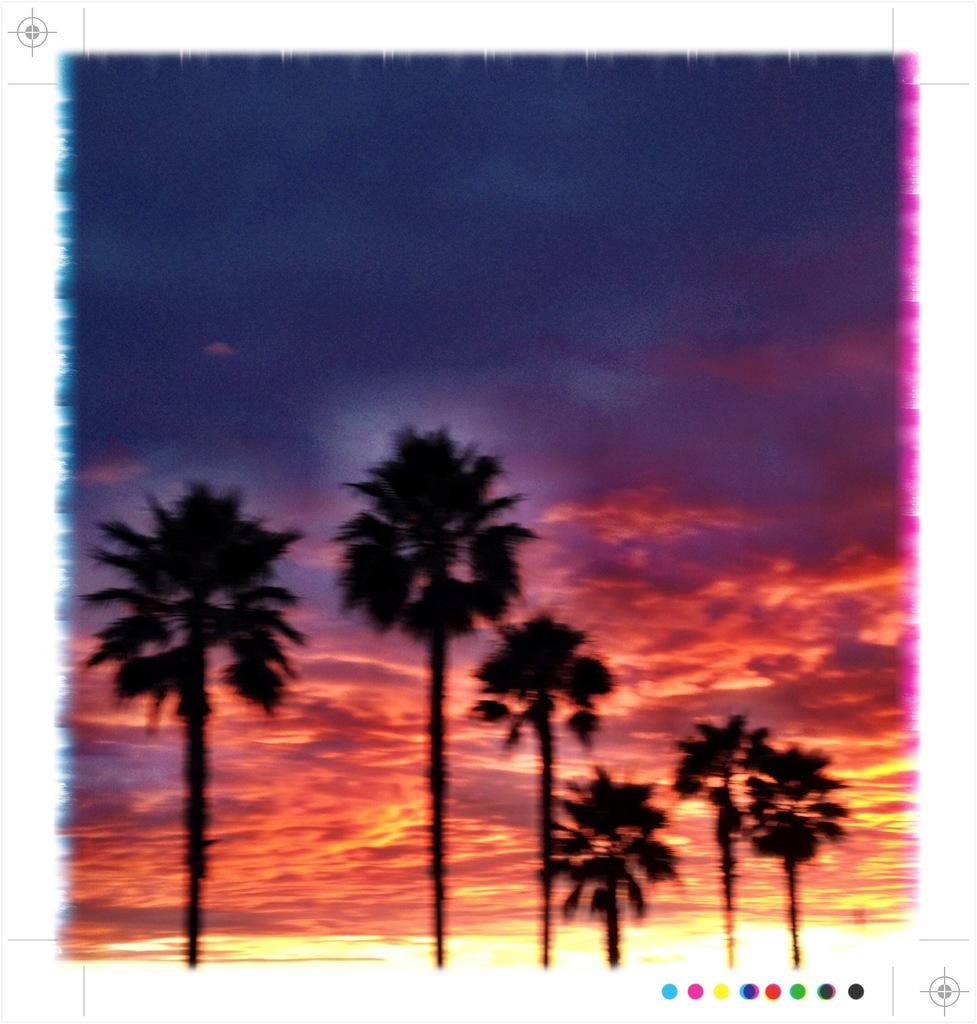What is located in the center of the image? There are trees in the center of the image. What can be seen in the background of the image? There is sky visible in the background of the image. Where is the secretary located in the image? There is no secretary present in the image; it only features trees and sky. What type of straw can be seen in the image? There is no straw present in the image. 